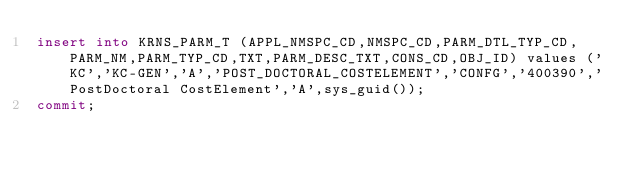Convert code to text. <code><loc_0><loc_0><loc_500><loc_500><_SQL_>insert into KRNS_PARM_T (APPL_NMSPC_CD,NMSPC_CD,PARM_DTL_TYP_CD,PARM_NM,PARM_TYP_CD,TXT,PARM_DESC_TXT,CONS_CD,OBJ_ID) values ('KC','KC-GEN','A','POST_DOCTORAL_COSTELEMENT','CONFG','400390','PostDoctoral CostElement','A',sys_guid());
commit;</code> 